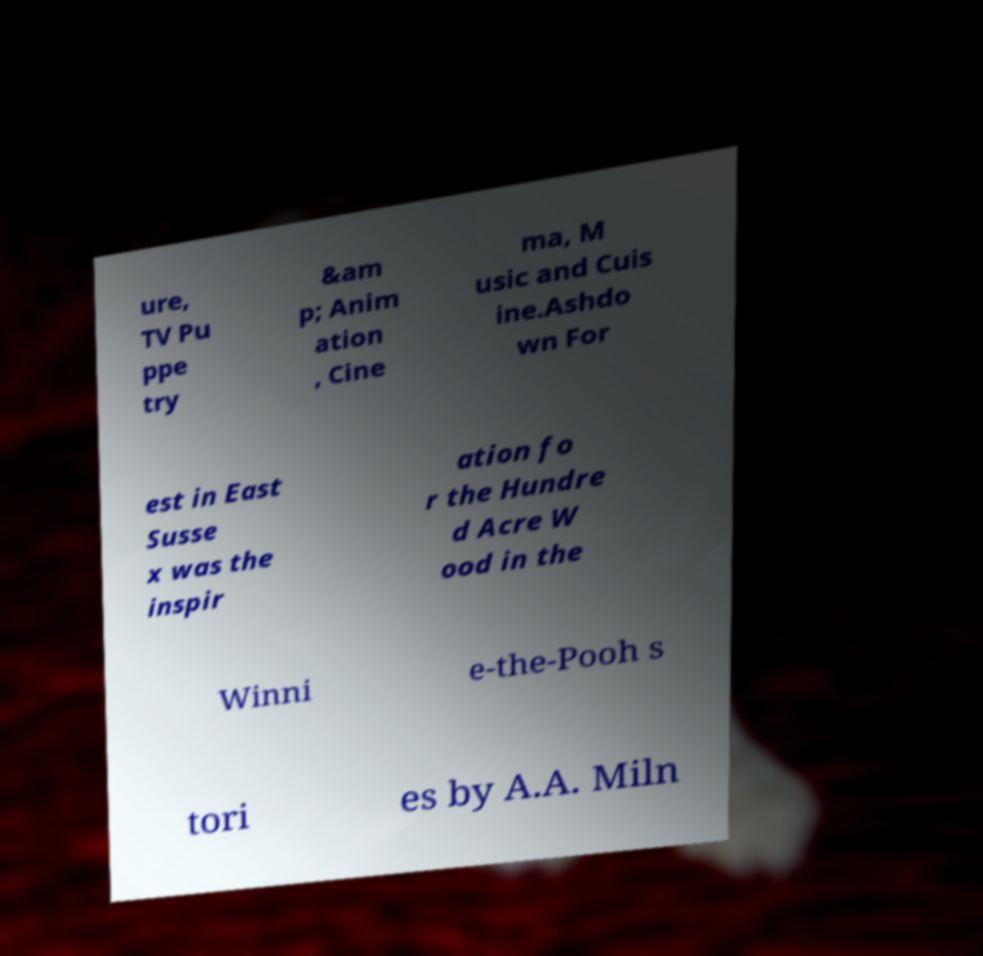Can you accurately transcribe the text from the provided image for me? ure, TV Pu ppe try &am p; Anim ation , Cine ma, M usic and Cuis ine.Ashdo wn For est in East Susse x was the inspir ation fo r the Hundre d Acre W ood in the Winni e-the-Pooh s tori es by A.A. Miln 